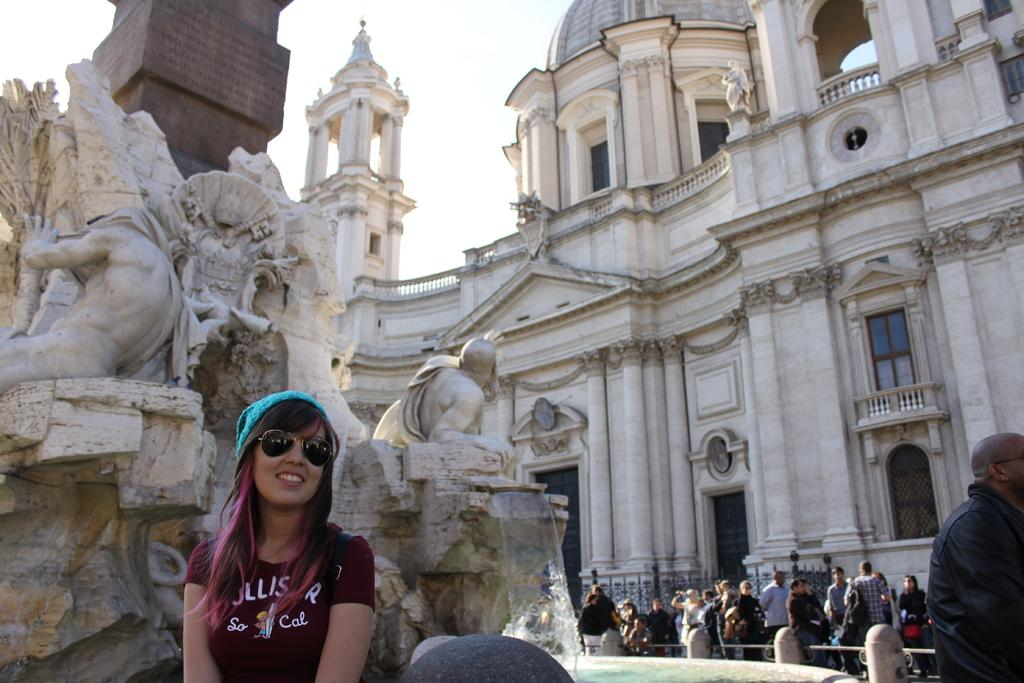Who or what can be seen in the image? There are people and sculptures in the image. What else is present in the image besides people and sculptures? There are buildings in the image. What can be seen in the background of the image? The sky is visible in the image. What type of jam is being served in the image? There is no jam present in the image; it features people, sculptures, buildings, and the sky. 